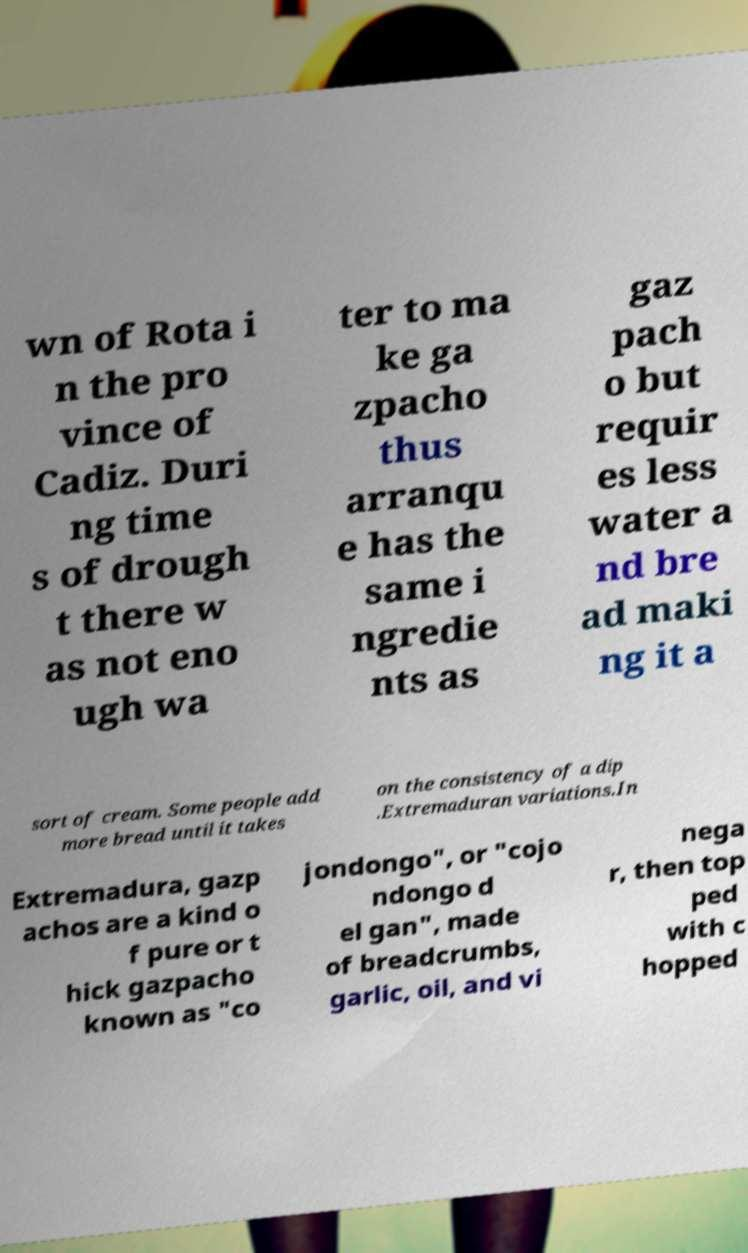For documentation purposes, I need the text within this image transcribed. Could you provide that? wn of Rota i n the pro vince of Cadiz. Duri ng time s of drough t there w as not eno ugh wa ter to ma ke ga zpacho thus arranqu e has the same i ngredie nts as gaz pach o but requir es less water a nd bre ad maki ng it a sort of cream. Some people add more bread until it takes on the consistency of a dip .Extremaduran variations.In Extremadura, gazp achos are a kind o f pure or t hick gazpacho known as "co jondongo", or "cojo ndongo d el gan", made of breadcrumbs, garlic, oil, and vi nega r, then top ped with c hopped 